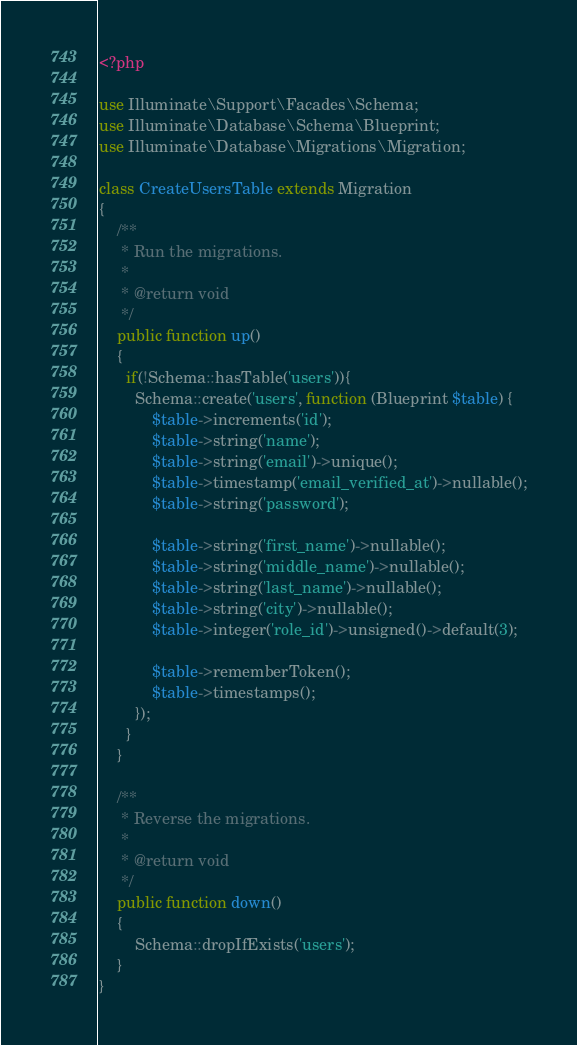Convert code to text. <code><loc_0><loc_0><loc_500><loc_500><_PHP_><?php

use Illuminate\Support\Facades\Schema;
use Illuminate\Database\Schema\Blueprint;
use Illuminate\Database\Migrations\Migration;

class CreateUsersTable extends Migration
{
    /**
     * Run the migrations.
     *
     * @return void
     */
    public function up()
    {
      if(!Schema::hasTable('users')){
        Schema::create('users', function (Blueprint $table) {
            $table->increments('id');
            $table->string('name');
            $table->string('email')->unique();
            $table->timestamp('email_verified_at')->nullable();
            $table->string('password');

            $table->string('first_name')->nullable();
            $table->string('middle_name')->nullable();
            $table->string('last_name')->nullable();
            $table->string('city')->nullable();
            $table->integer('role_id')->unsigned()->default(3);

            $table->rememberToken();
            $table->timestamps();
        });
      }
    }

    /**
     * Reverse the migrations.
     *
     * @return void
     */
    public function down()
    {
        Schema::dropIfExists('users');
    }
}
</code> 